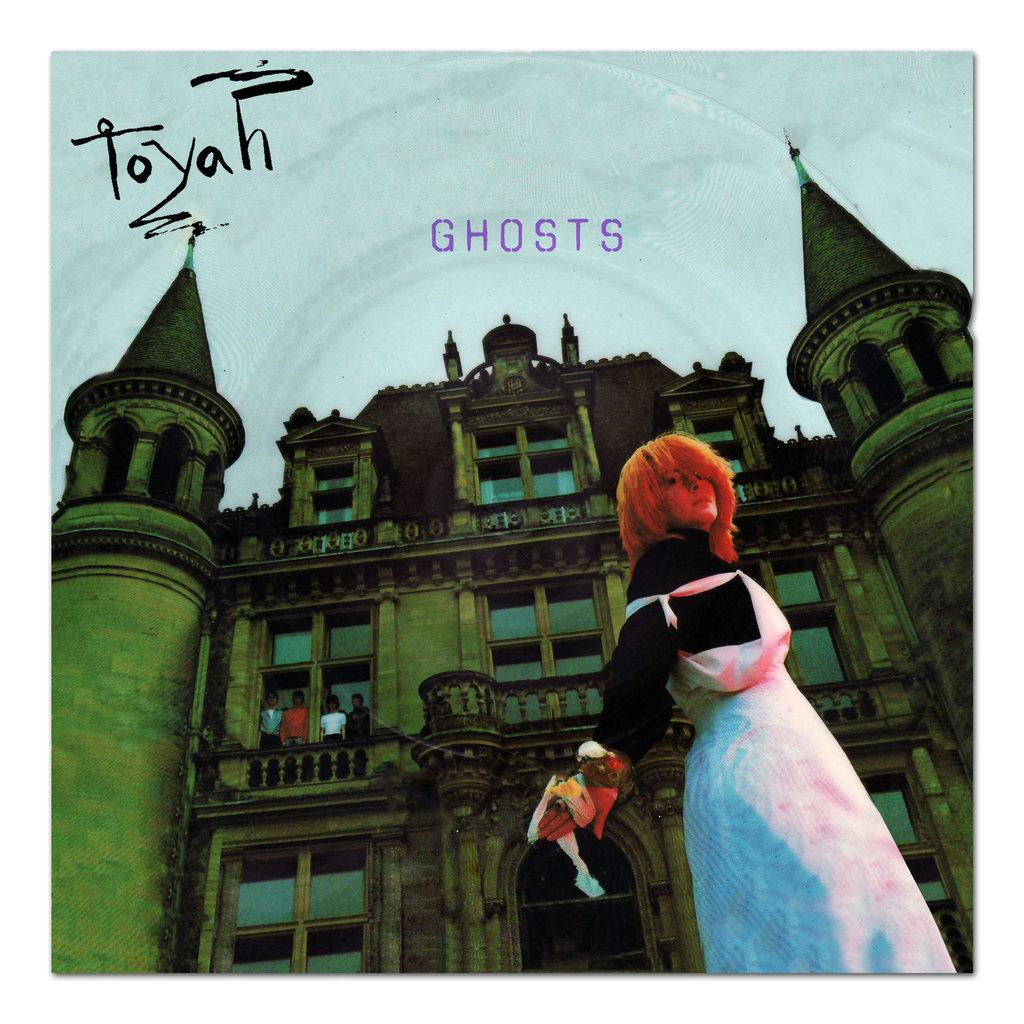Who is present in the image? There is a woman in the image. What is the woman wearing? The woman is wearing a costume. What can be seen in the background of the image? There is a building in the background of the image. Are there any other people visible in the image? Yes, there are people visible near the building. What is written on the top of the building? There is text visible on the top of the building. Is the river near the building in the image quiet or noisy? There is no river present in the image, so it is not possible to determine if it is quiet or noisy. What type of poison is being used by the woman in the image? There is no indication of poison in the image, as the woman is wearing a costume and there are no other signs of poisonous substances. 